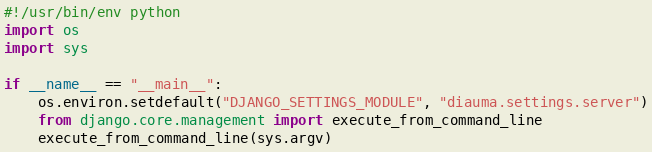<code> <loc_0><loc_0><loc_500><loc_500><_Python_>#!/usr/bin/env python
import os
import sys

if __name__ == "__main__":
    os.environ.setdefault("DJANGO_SETTINGS_MODULE", "diauma.settings.server")
    from django.core.management import execute_from_command_line
    execute_from_command_line(sys.argv)
</code> 